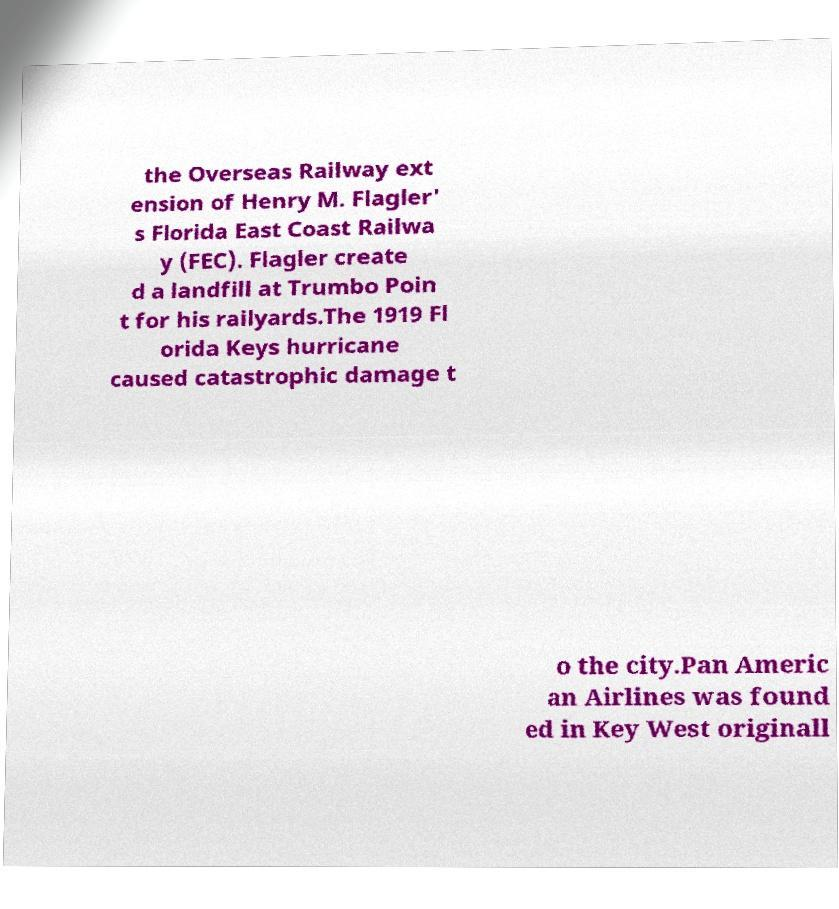There's text embedded in this image that I need extracted. Can you transcribe it verbatim? the Overseas Railway ext ension of Henry M. Flagler' s Florida East Coast Railwa y (FEC). Flagler create d a landfill at Trumbo Poin t for his railyards.The 1919 Fl orida Keys hurricane caused catastrophic damage t o the city.Pan Americ an Airlines was found ed in Key West originall 